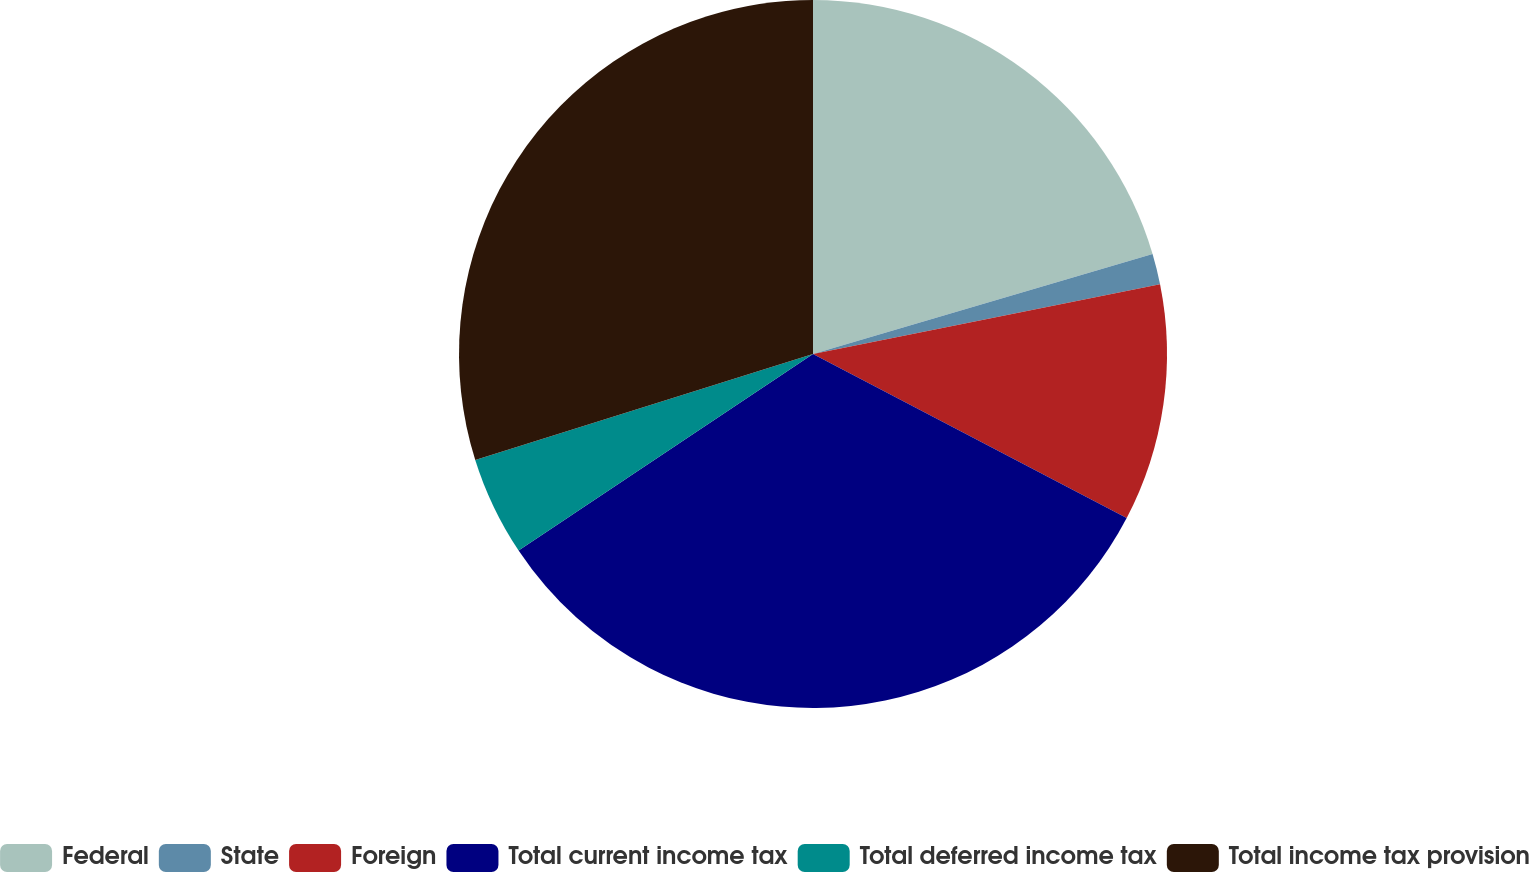Convert chart to OTSL. <chart><loc_0><loc_0><loc_500><loc_500><pie_chart><fcel>Federal<fcel>State<fcel>Foreign<fcel>Total current income tax<fcel>Total deferred income tax<fcel>Total income tax provision<nl><fcel>20.44%<fcel>1.4%<fcel>10.83%<fcel>32.96%<fcel>4.53%<fcel>29.84%<nl></chart> 